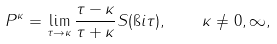<formula> <loc_0><loc_0><loc_500><loc_500>P ^ { \kappa } = \lim _ { \tau \rightarrow \kappa } \frac { \tau - \kappa } { \tau + \kappa } S ( \i i \tau ) , \quad \kappa \neq 0 , \infty ,</formula> 